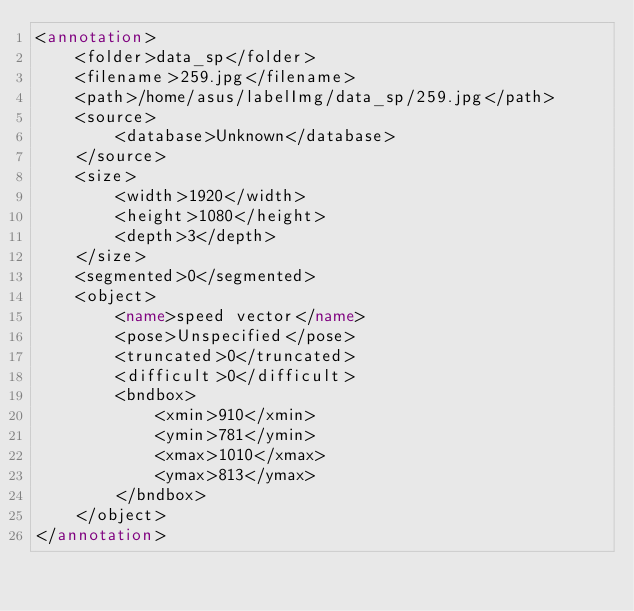Convert code to text. <code><loc_0><loc_0><loc_500><loc_500><_XML_><annotation>
	<folder>data_sp</folder>
	<filename>259.jpg</filename>
	<path>/home/asus/labelImg/data_sp/259.jpg</path>
	<source>
		<database>Unknown</database>
	</source>
	<size>
		<width>1920</width>
		<height>1080</height>
		<depth>3</depth>
	</size>
	<segmented>0</segmented>
	<object>
		<name>speed vector</name>
		<pose>Unspecified</pose>
		<truncated>0</truncated>
		<difficult>0</difficult>
		<bndbox>
			<xmin>910</xmin>
			<ymin>781</ymin>
			<xmax>1010</xmax>
			<ymax>813</ymax>
		</bndbox>
	</object>
</annotation>
</code> 